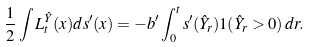<formula> <loc_0><loc_0><loc_500><loc_500>\frac { 1 } { 2 } \int L _ { t } ^ { \hat { Y } } ( x ) d s ^ { \prime } ( x ) = - b ^ { \prime } \int _ { 0 } ^ { t } s ^ { \prime } ( \hat { Y } _ { r } ) 1 ( \hat { Y } _ { r } > 0 ) \, d r .</formula> 